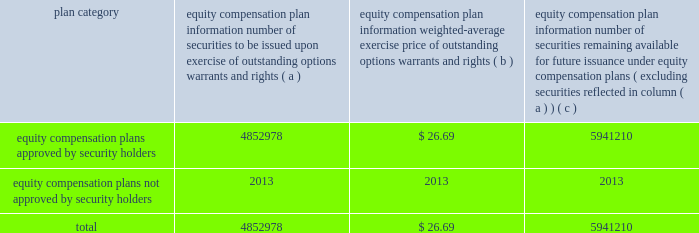Page 92 of 98 other information required by item 10 appearing under the caption 201cdirector nominees and continuing directors 201d and 201csection 16 ( a ) beneficial ownership reporting compliance , 201d of the company 2019s proxy statement to be filed pursuant to regulation 14a within 120 days after december 31 , 2006 , is incorporated herein by reference .
Item 11 .
Executive compensation the information required by item 11 appearing under the caption 201cexecutive compensation 201d in the company 2019s proxy statement , to be filed pursuant to regulation 14a within 120 days after december 31 , 2006 , is incorporated herein by reference .
Additionally , the ball corporation 2000 deferred compensation company stock plan , the ball corporation deposit share program and the ball corporation directors deposit share program were created to encourage key executives and other participants to acquire a larger equity ownership interest in the company and to increase their interest in the company 2019s stock performance .
Non-employee directors also participate in the 2000 deferred compensation company stock plan .
Item 12 .
Security ownership of certain beneficial owners and management the information required by item 12 appearing under the caption 201cvoting securities and principal shareholders , 201d in the company 2019s proxy statement to be filed pursuant to regulation 14a within 120 days after december 31 , 2006 , is incorporated herein by reference .
Securities authorized for issuance under equity compensation plans are summarized below: .
Item 13 .
Certain relationships and related transactions the information required by item 13 appearing under the caption 201cratification of the appointment of independent registered public accounting firm , 201d in the company 2019s proxy statement to be filed pursuant to regulation 14a within 120 days after december 31 , 2006 , is incorporated herein by reference .
Item 14 .
Principal accountant fees and services the information required by item 14 appearing under the caption 201ccertain committees of the board , 201d in the company 2019s proxy statement to be filed pursuant to regulation 14a within 120 days after december 31 , 2006 , is incorporated herein by reference. .
What is the total value of the shares already issued under the equity compensation plans for 2006? 
Computations: (4852978 * 26.69)
Answer: 129525982.82. 